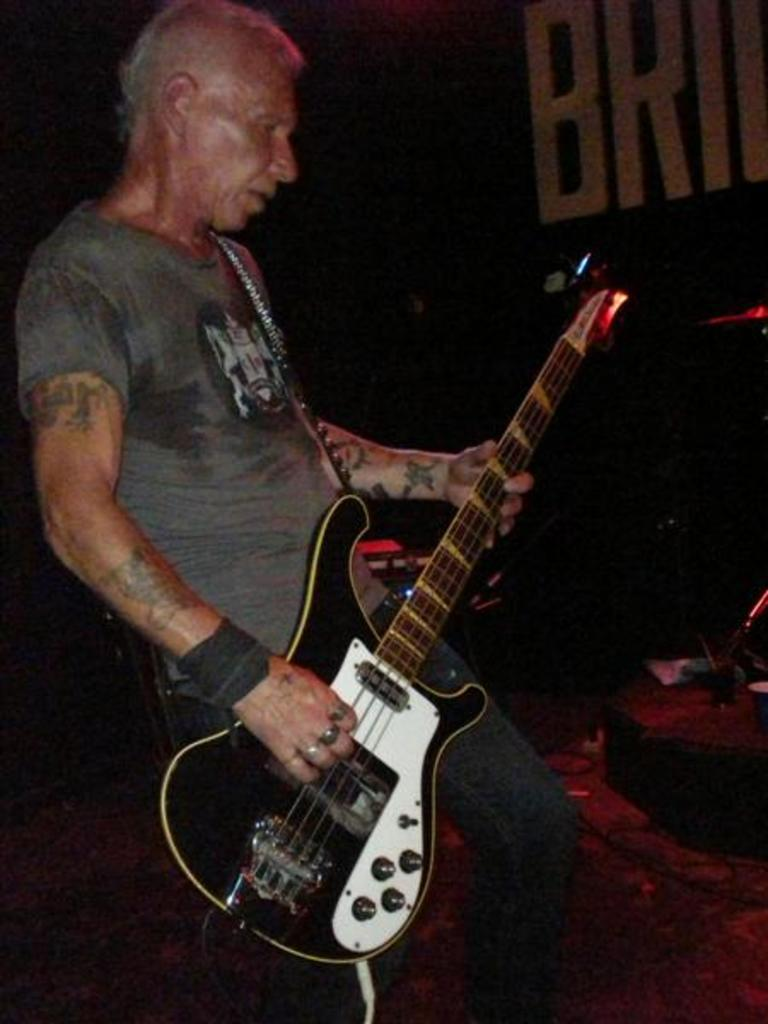What is the man in the image doing? The man is playing a guitar in the image. What is the man wearing in the image? The man is wearing a green t-shirt in the image. Are there any accessories visible on the man's hand? Yes, there is a band on the man's hand and rings on his fingers in the image. What can be seen on the right side of the image? There is an item on the right side of the image, but its specific nature is not mentioned in the provided facts. What type of curve can be seen in the field behind the man in the image? There is no field or curve visible in the image; it features a man playing a guitar with a band on his hand and rings on his fingers. 